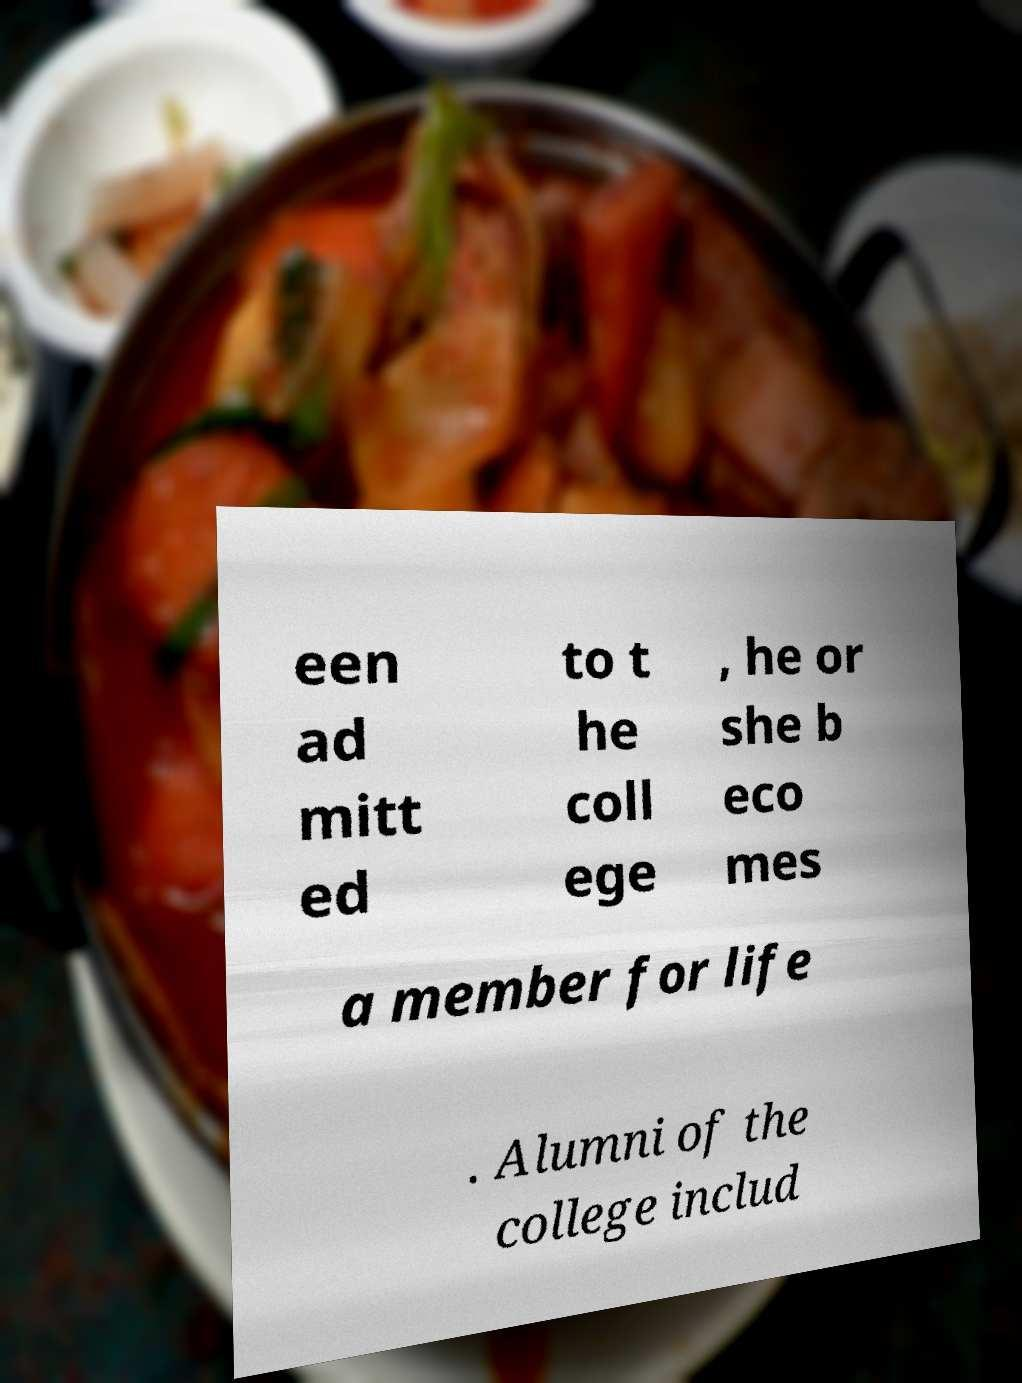Could you assist in decoding the text presented in this image and type it out clearly? een ad mitt ed to t he coll ege , he or she b eco mes a member for life . Alumni of the college includ 